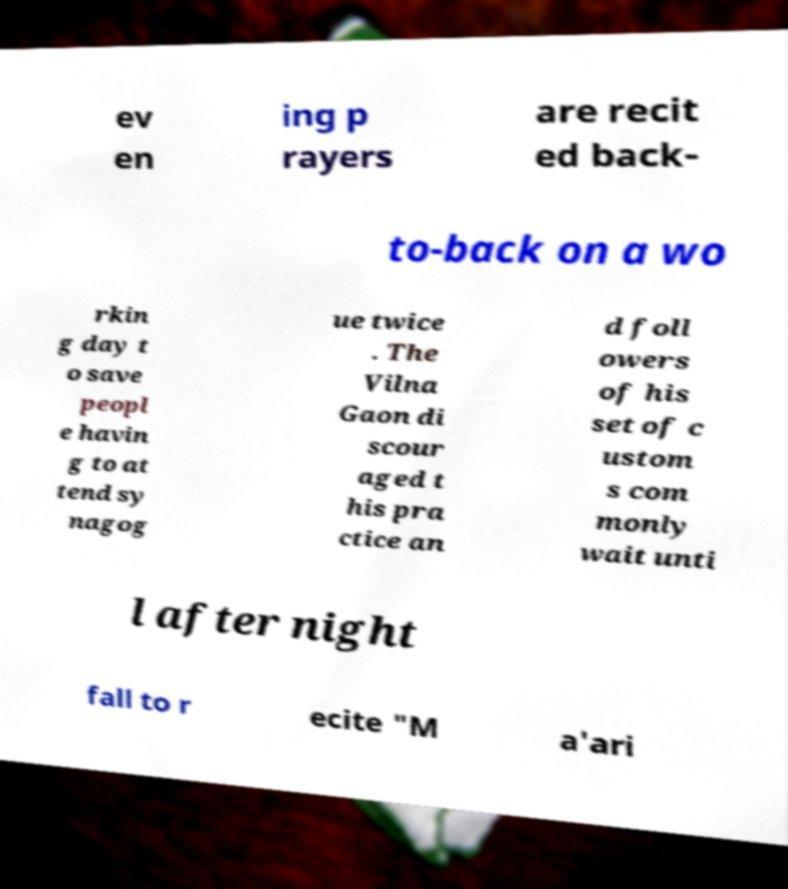Can you accurately transcribe the text from the provided image for me? ev en ing p rayers are recit ed back- to-back on a wo rkin g day t o save peopl e havin g to at tend sy nagog ue twice . The Vilna Gaon di scour aged t his pra ctice an d foll owers of his set of c ustom s com monly wait unti l after night fall to r ecite "M a'ari 